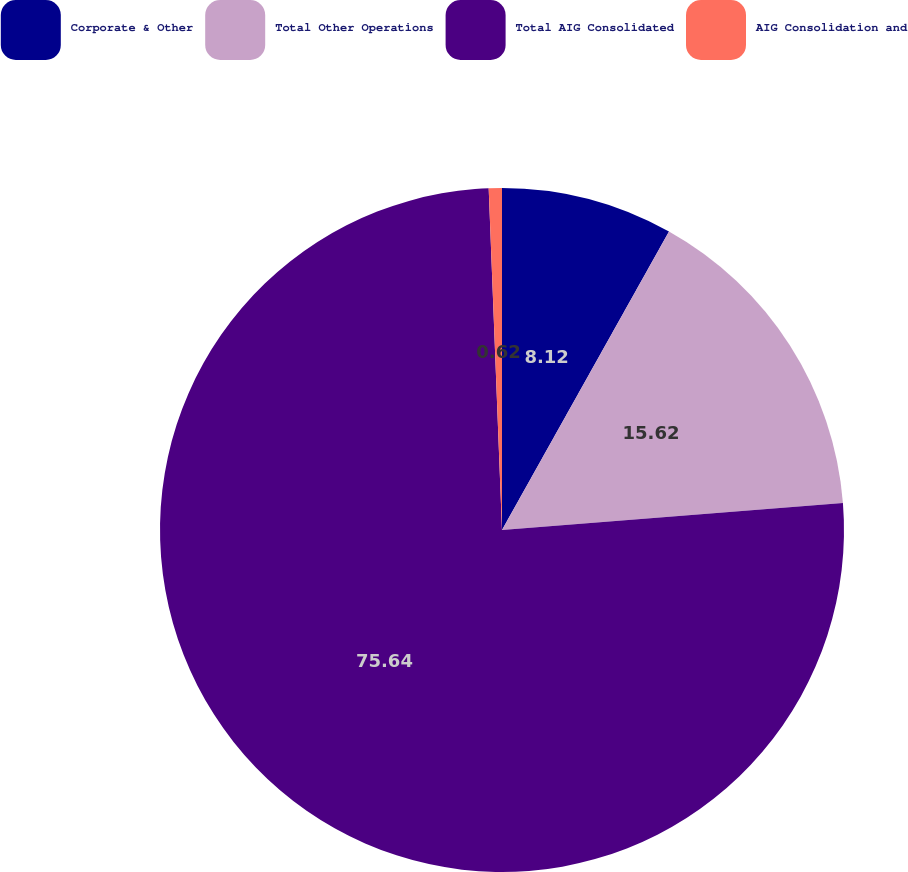Convert chart. <chart><loc_0><loc_0><loc_500><loc_500><pie_chart><fcel>Corporate & Other<fcel>Total Other Operations<fcel>Total AIG Consolidated<fcel>AIG Consolidation and<nl><fcel>8.12%<fcel>15.62%<fcel>75.64%<fcel>0.62%<nl></chart> 